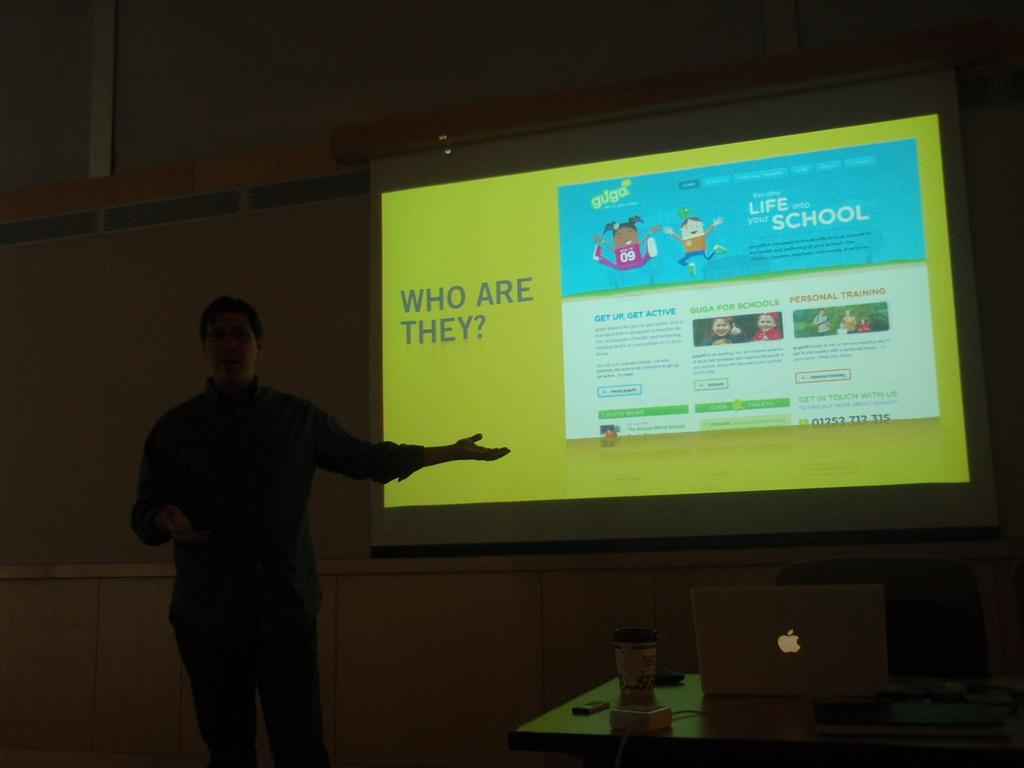Where is the image taken? The image is taken in a room. What can be seen on one of the walls in the room? There is a screen in the room. What piece of furniture is on the right side of the room? There is a table on the right side of the room. What is the person in the room doing? The presence of a laptop, CPU, and mobile phone on the table suggests that the person might be working or using electronic devices. Can you see the person's grandmother in the image? There is no mention of a grandmother in the image, so we cannot determine if she is present or not. What type of tooth is visible on the table in the image? There is no tooth present on the table in the image. Is there a chicken on the table in the image? There is no chicken present on the table in the image. 